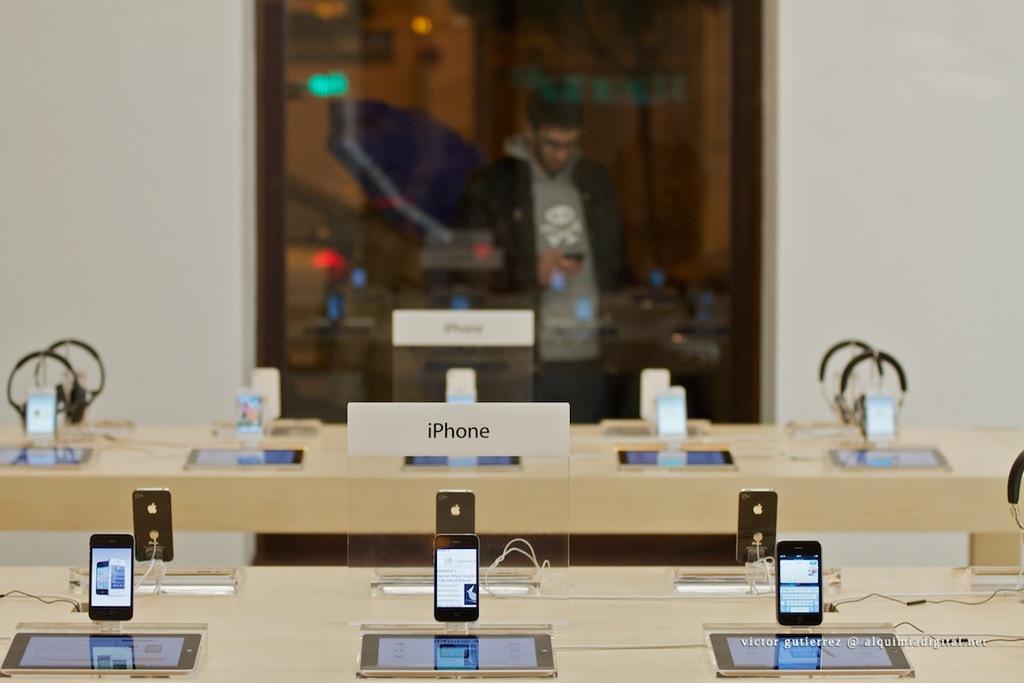What person's name is mentioned in the bottom right?
Offer a terse response. Victor gutierrez. What is the brand of phone shown here?
Keep it short and to the point. Iphone. 